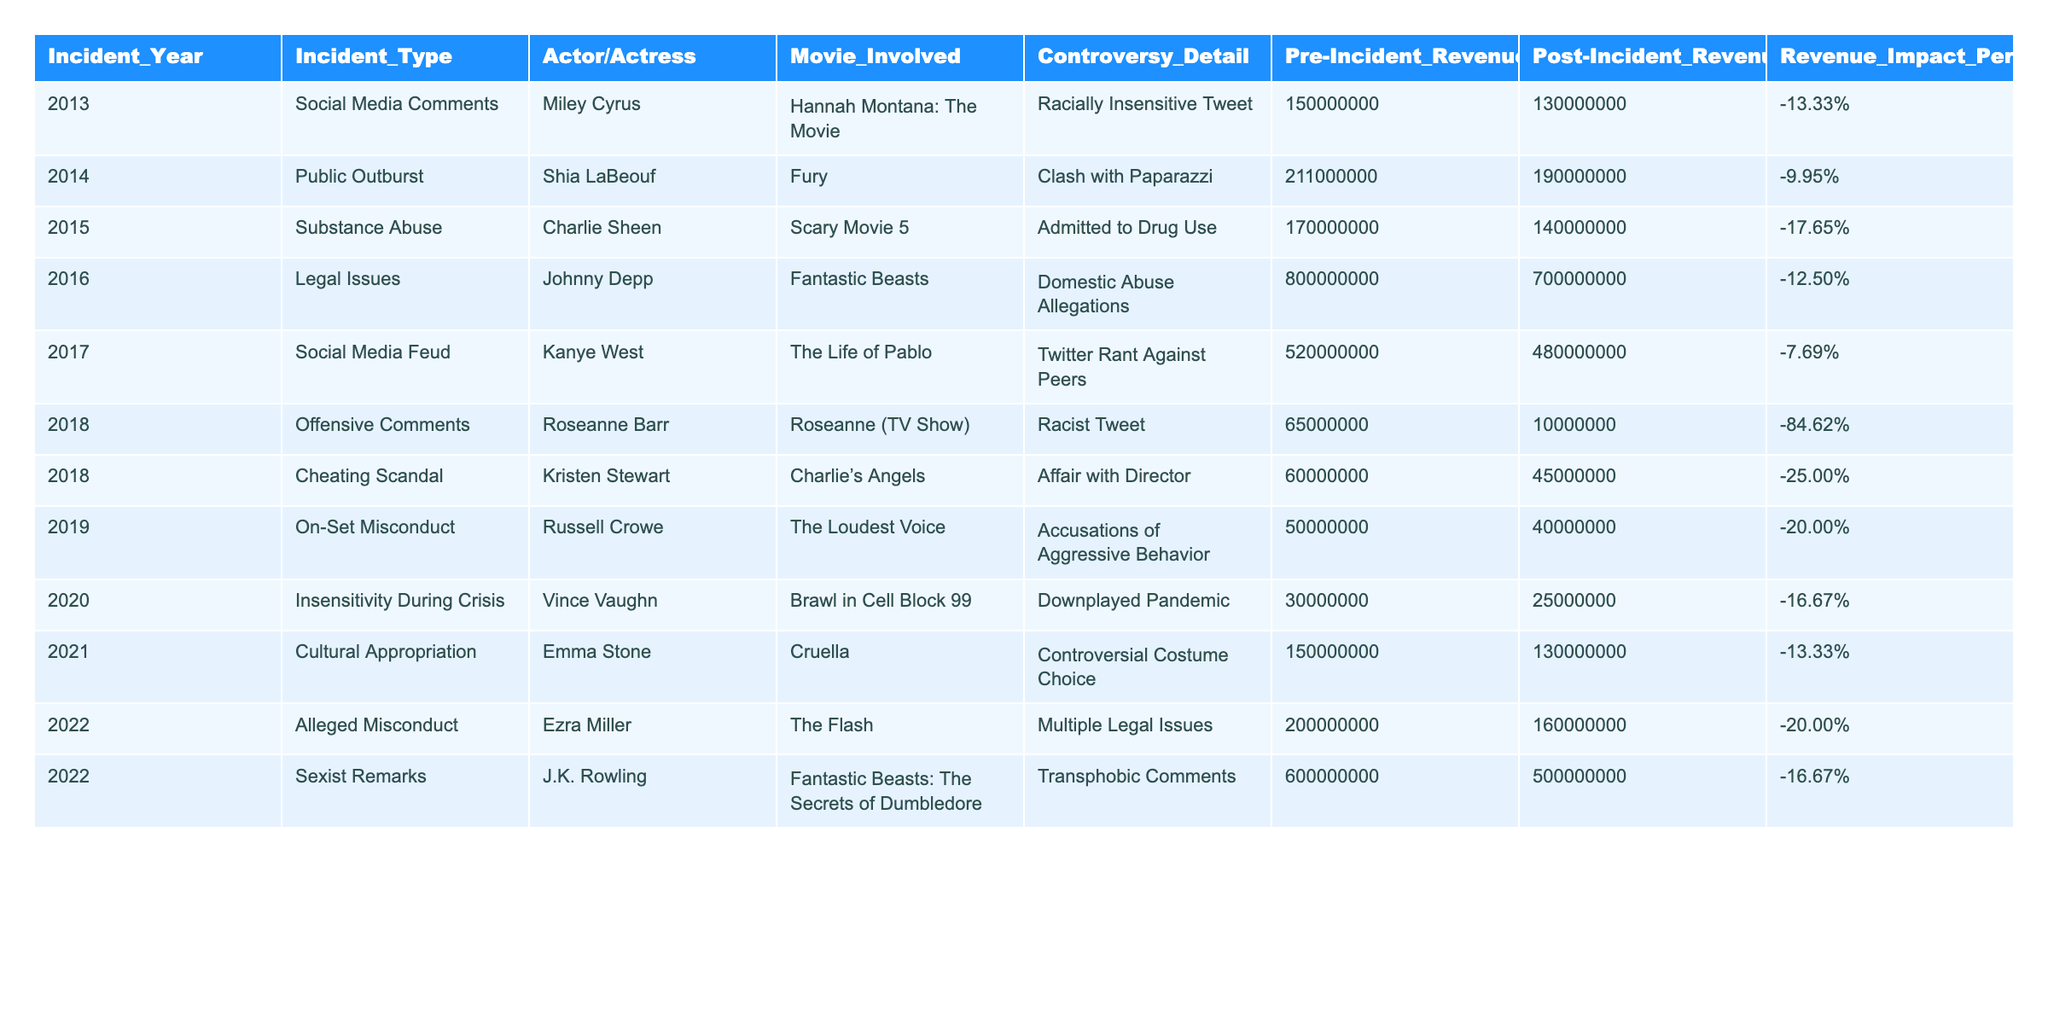What was the revenue impact percentage for Miley Cyrus's incident in 2013? The table shows that Miley Cyrus's pre-incident revenue was 150,000,000 USD, and her post-incident revenue was 130,000,000 USD. The revenue impact percentage is calculated as ((130000000 - 150000000) / 150000000) * 100 = -13.33%.
Answer: -13.33% Which incident had the highest revenue impact percentage? By reviewing the revenue impact percentages in the table, Roseanne Barr's incident in 2018 shows the highest impact at -84.62%.
Answer: -84.62% What was the total pre-incident revenue for all incidents listed? To find the total pre-incident revenue, we sum all the pre-incident values from the table: 150000000 + 211000000 + 170000000 + 800000000 + 520000000 + 65000000 + 60000000 + 50000000 + 30000000 + 150000000 + 200000000 + 600000000 = 1865000000 USD.
Answer: 1865000000 USD Did any incident lead to an increase in revenue post-incident? By analyzing the post-incident revenue values for each incident, all cases show a decrease in revenue after the controversy. Thus, there was no incident that led to an increase in post-incident revenue.
Answer: No What is the average revenue impact percentage for all incidents involving legal issues? There are two entries in the table regarding legal issues: Johnny Depp (-12.50%) and Ezra Miller (-20.00%). To find the average, we sum the percentages: (-12.50 + -20.00) / 2 = -16.25%.
Answer: -16.25% 